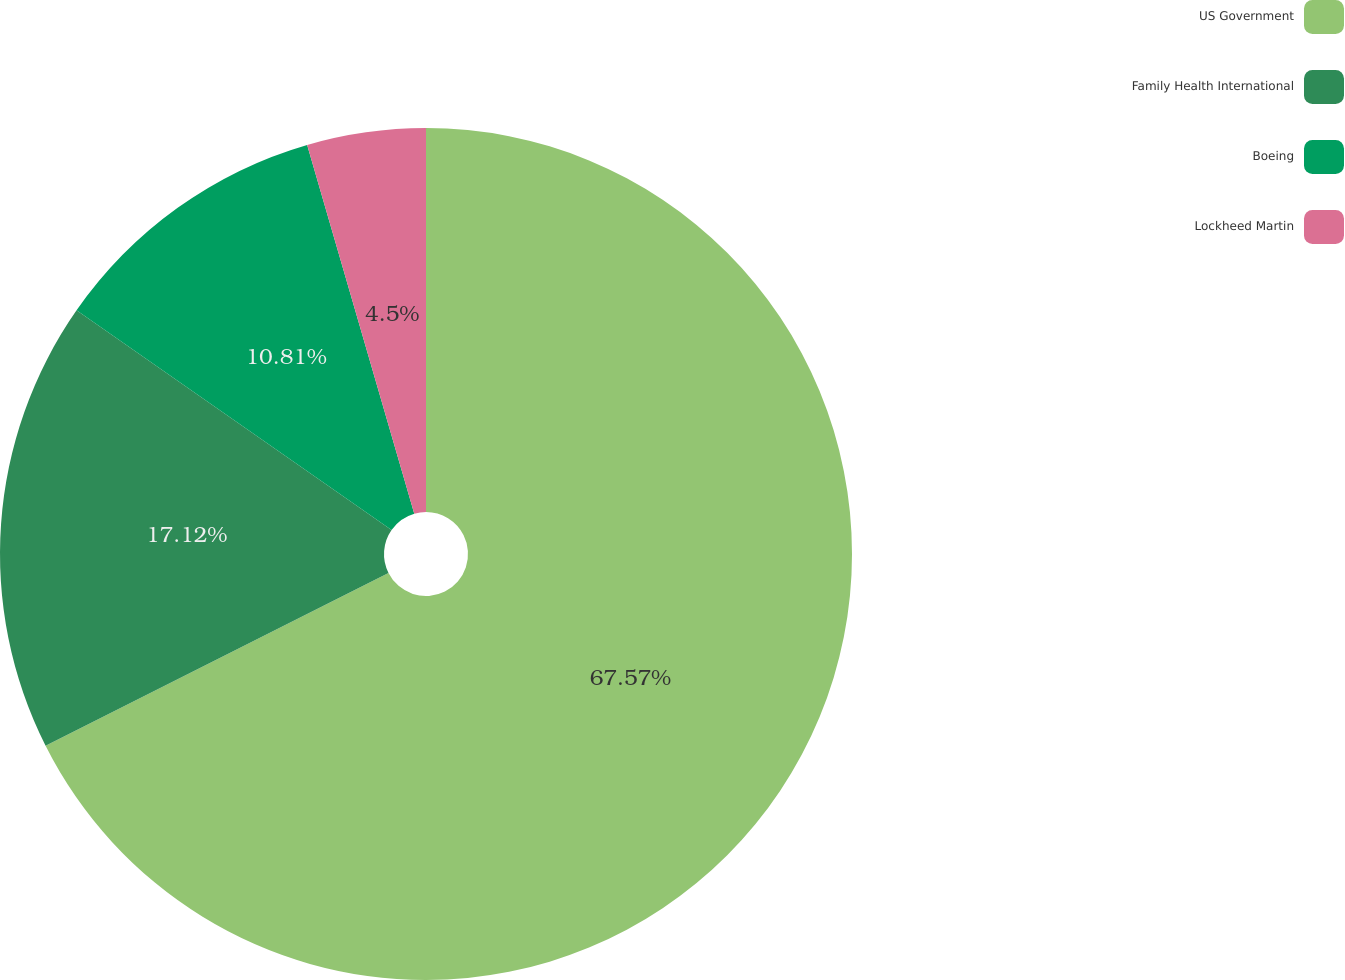Convert chart. <chart><loc_0><loc_0><loc_500><loc_500><pie_chart><fcel>US Government<fcel>Family Health International<fcel>Boeing<fcel>Lockheed Martin<nl><fcel>67.57%<fcel>17.12%<fcel>10.81%<fcel>4.5%<nl></chart> 